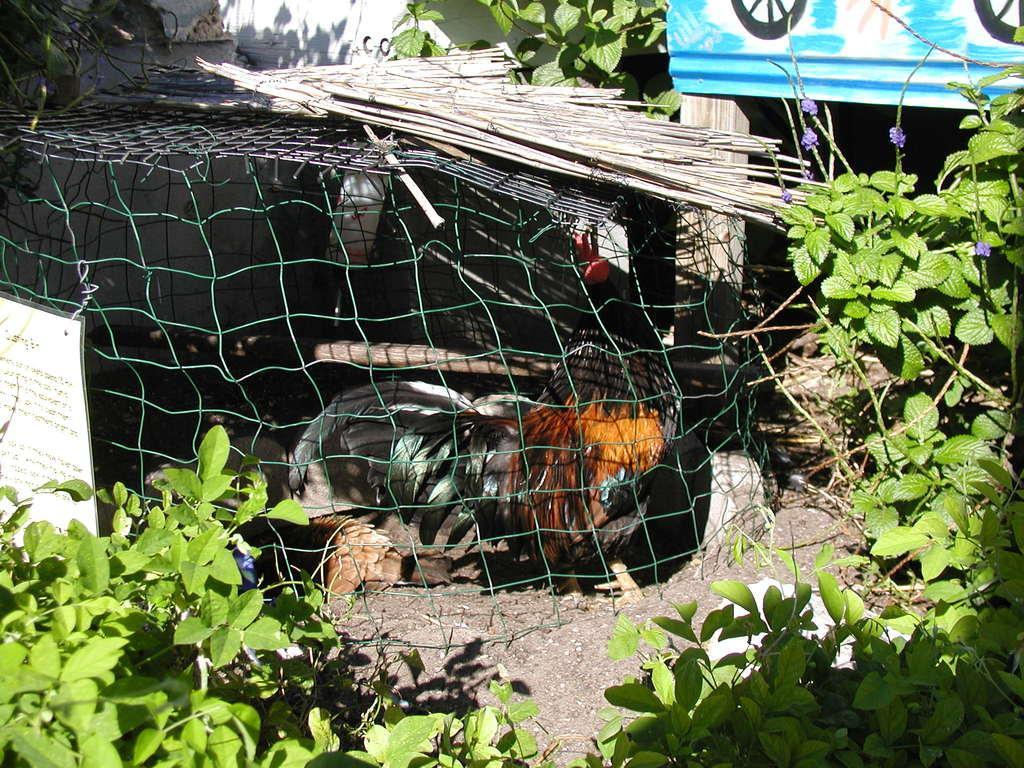In one or two sentences, can you explain what this image depicts? In this image I can see plants, a black and brown colour chicken, a paper, a blue colour board and on this paper I can see something is written. 